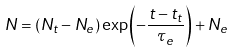Convert formula to latex. <formula><loc_0><loc_0><loc_500><loc_500>N = ( N _ { t } - N _ { e } ) \exp \left ( - \frac { t - t _ { t } } { \tau _ { e } } \right ) + N _ { e }</formula> 